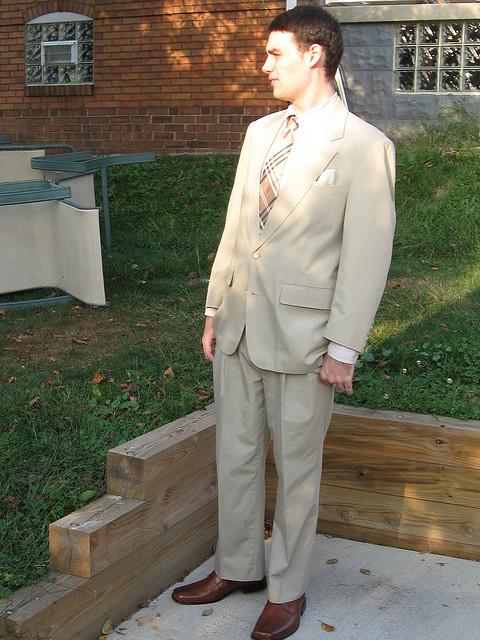Is the man dressed as a businessman?
Answer briefly. Yes. Is the guy wearing a tailored suit?
Keep it brief. Yes. Is the man standing in the sun?
Give a very brief answer. Yes. Is this a kid?
Be succinct. No. What is the man thinking about?
Answer briefly. Food. Are there weeds in the grass?
Concise answer only. Yes. 